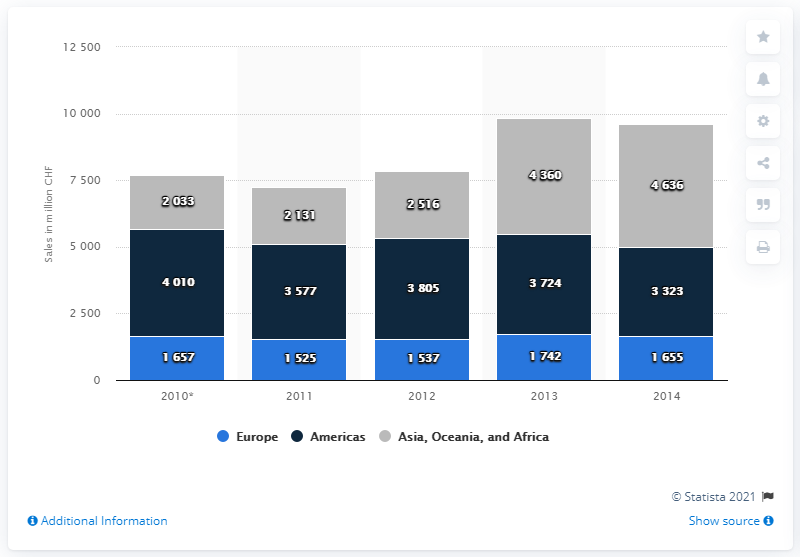List a handful of essential elements in this visual. In 2013, the sales of Nestlé Nutrition in Europe totaled 1,742. 